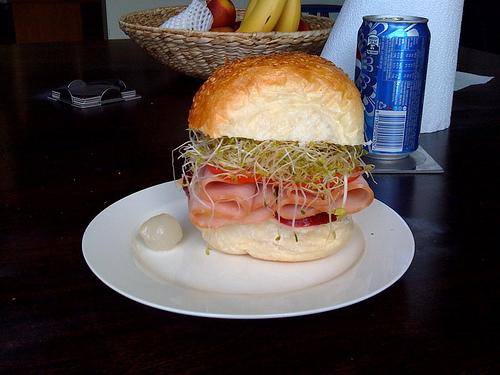What kind of meat is on the sandwich?
Keep it brief. Ham. What could a person create with the ingredients show in the image?
Answer briefly. Sandwich. What color is the soda can?
Answer briefly. Blue. What is the white vegetable on the plate?
Concise answer only. Onion. 